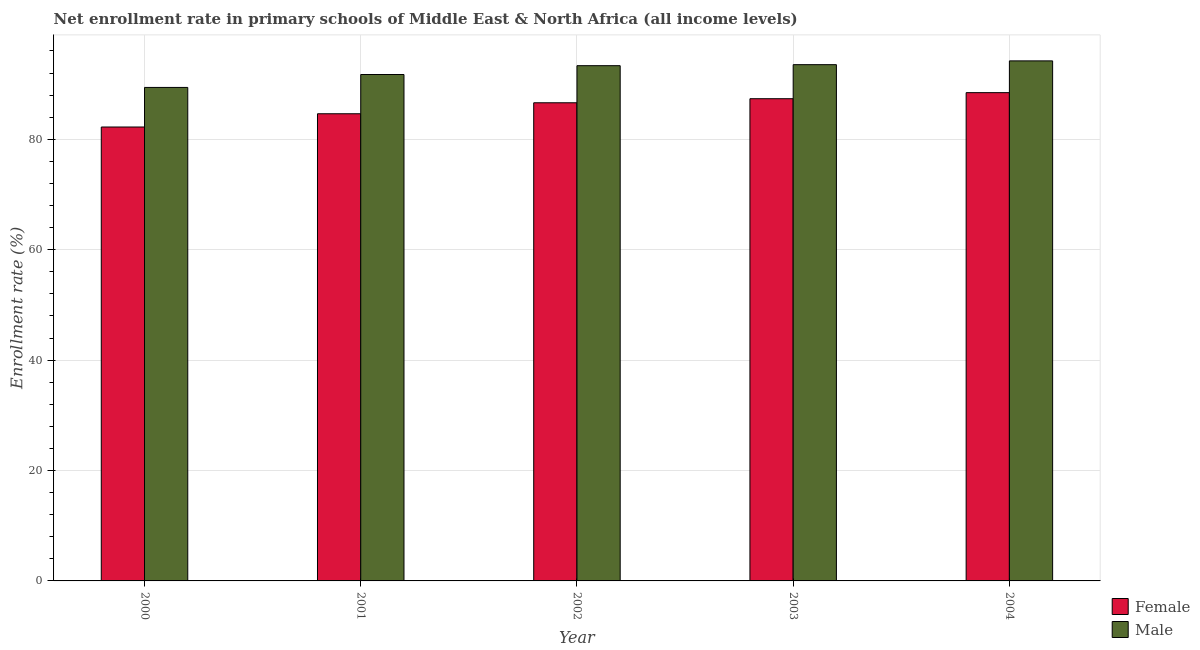How many different coloured bars are there?
Offer a terse response. 2. How many bars are there on the 3rd tick from the left?
Your response must be concise. 2. How many bars are there on the 1st tick from the right?
Your response must be concise. 2. In how many cases, is the number of bars for a given year not equal to the number of legend labels?
Your answer should be very brief. 0. What is the enrollment rate of female students in 2002?
Your answer should be compact. 86.61. Across all years, what is the maximum enrollment rate of male students?
Make the answer very short. 94.2. Across all years, what is the minimum enrollment rate of male students?
Make the answer very short. 89.39. In which year was the enrollment rate of female students maximum?
Offer a very short reply. 2004. In which year was the enrollment rate of female students minimum?
Keep it short and to the point. 2000. What is the total enrollment rate of female students in the graph?
Keep it short and to the point. 429.24. What is the difference between the enrollment rate of male students in 2000 and that in 2003?
Your response must be concise. -4.12. What is the difference between the enrollment rate of male students in 2001 and the enrollment rate of female students in 2000?
Your answer should be very brief. 2.34. What is the average enrollment rate of female students per year?
Give a very brief answer. 85.85. In the year 2004, what is the difference between the enrollment rate of female students and enrollment rate of male students?
Provide a succinct answer. 0. What is the ratio of the enrollment rate of female students in 2002 to that in 2003?
Give a very brief answer. 0.99. What is the difference between the highest and the second highest enrollment rate of female students?
Provide a short and direct response. 1.1. What is the difference between the highest and the lowest enrollment rate of female students?
Keep it short and to the point. 6.22. Is the sum of the enrollment rate of male students in 2001 and 2002 greater than the maximum enrollment rate of female students across all years?
Give a very brief answer. Yes. How many bars are there?
Ensure brevity in your answer.  10. Are all the bars in the graph horizontal?
Provide a succinct answer. No. What is the title of the graph?
Keep it short and to the point. Net enrollment rate in primary schools of Middle East & North Africa (all income levels). What is the label or title of the X-axis?
Make the answer very short. Year. What is the label or title of the Y-axis?
Ensure brevity in your answer.  Enrollment rate (%). What is the Enrollment rate (%) of Female in 2000?
Make the answer very short. 82.22. What is the Enrollment rate (%) of Male in 2000?
Provide a short and direct response. 89.39. What is the Enrollment rate (%) of Female in 2001?
Your response must be concise. 84.62. What is the Enrollment rate (%) of Male in 2001?
Your response must be concise. 91.73. What is the Enrollment rate (%) in Female in 2002?
Offer a very short reply. 86.61. What is the Enrollment rate (%) in Male in 2002?
Your answer should be very brief. 93.33. What is the Enrollment rate (%) in Female in 2003?
Keep it short and to the point. 87.35. What is the Enrollment rate (%) of Male in 2003?
Provide a short and direct response. 93.51. What is the Enrollment rate (%) in Female in 2004?
Ensure brevity in your answer.  88.44. What is the Enrollment rate (%) in Male in 2004?
Your answer should be very brief. 94.2. Across all years, what is the maximum Enrollment rate (%) of Female?
Make the answer very short. 88.44. Across all years, what is the maximum Enrollment rate (%) of Male?
Provide a succinct answer. 94.2. Across all years, what is the minimum Enrollment rate (%) in Female?
Ensure brevity in your answer.  82.22. Across all years, what is the minimum Enrollment rate (%) of Male?
Offer a very short reply. 89.39. What is the total Enrollment rate (%) of Female in the graph?
Provide a succinct answer. 429.24. What is the total Enrollment rate (%) of Male in the graph?
Keep it short and to the point. 462.16. What is the difference between the Enrollment rate (%) of Female in 2000 and that in 2001?
Offer a terse response. -2.4. What is the difference between the Enrollment rate (%) in Male in 2000 and that in 2001?
Provide a succinct answer. -2.34. What is the difference between the Enrollment rate (%) of Female in 2000 and that in 2002?
Offer a very short reply. -4.39. What is the difference between the Enrollment rate (%) of Male in 2000 and that in 2002?
Provide a short and direct response. -3.94. What is the difference between the Enrollment rate (%) in Female in 2000 and that in 2003?
Offer a very short reply. -5.13. What is the difference between the Enrollment rate (%) in Male in 2000 and that in 2003?
Offer a terse response. -4.12. What is the difference between the Enrollment rate (%) of Female in 2000 and that in 2004?
Ensure brevity in your answer.  -6.22. What is the difference between the Enrollment rate (%) of Male in 2000 and that in 2004?
Offer a very short reply. -4.81. What is the difference between the Enrollment rate (%) of Female in 2001 and that in 2002?
Keep it short and to the point. -1.99. What is the difference between the Enrollment rate (%) in Male in 2001 and that in 2002?
Give a very brief answer. -1.6. What is the difference between the Enrollment rate (%) in Female in 2001 and that in 2003?
Your answer should be very brief. -2.73. What is the difference between the Enrollment rate (%) of Male in 2001 and that in 2003?
Make the answer very short. -1.78. What is the difference between the Enrollment rate (%) of Female in 2001 and that in 2004?
Ensure brevity in your answer.  -3.82. What is the difference between the Enrollment rate (%) of Male in 2001 and that in 2004?
Offer a very short reply. -2.47. What is the difference between the Enrollment rate (%) of Female in 2002 and that in 2003?
Your answer should be very brief. -0.74. What is the difference between the Enrollment rate (%) of Male in 2002 and that in 2003?
Make the answer very short. -0.18. What is the difference between the Enrollment rate (%) in Female in 2002 and that in 2004?
Provide a short and direct response. -1.84. What is the difference between the Enrollment rate (%) of Male in 2002 and that in 2004?
Your response must be concise. -0.87. What is the difference between the Enrollment rate (%) in Female in 2003 and that in 2004?
Provide a succinct answer. -1.1. What is the difference between the Enrollment rate (%) in Male in 2003 and that in 2004?
Provide a succinct answer. -0.69. What is the difference between the Enrollment rate (%) of Female in 2000 and the Enrollment rate (%) of Male in 2001?
Provide a short and direct response. -9.51. What is the difference between the Enrollment rate (%) of Female in 2000 and the Enrollment rate (%) of Male in 2002?
Offer a terse response. -11.11. What is the difference between the Enrollment rate (%) of Female in 2000 and the Enrollment rate (%) of Male in 2003?
Your answer should be compact. -11.29. What is the difference between the Enrollment rate (%) of Female in 2000 and the Enrollment rate (%) of Male in 2004?
Make the answer very short. -11.98. What is the difference between the Enrollment rate (%) of Female in 2001 and the Enrollment rate (%) of Male in 2002?
Provide a short and direct response. -8.71. What is the difference between the Enrollment rate (%) of Female in 2001 and the Enrollment rate (%) of Male in 2003?
Offer a very short reply. -8.89. What is the difference between the Enrollment rate (%) of Female in 2001 and the Enrollment rate (%) of Male in 2004?
Make the answer very short. -9.58. What is the difference between the Enrollment rate (%) of Female in 2002 and the Enrollment rate (%) of Male in 2003?
Provide a succinct answer. -6.9. What is the difference between the Enrollment rate (%) of Female in 2002 and the Enrollment rate (%) of Male in 2004?
Provide a succinct answer. -7.59. What is the difference between the Enrollment rate (%) in Female in 2003 and the Enrollment rate (%) in Male in 2004?
Offer a very short reply. -6.85. What is the average Enrollment rate (%) of Female per year?
Provide a succinct answer. 85.85. What is the average Enrollment rate (%) of Male per year?
Your answer should be very brief. 92.43. In the year 2000, what is the difference between the Enrollment rate (%) in Female and Enrollment rate (%) in Male?
Your answer should be compact. -7.17. In the year 2001, what is the difference between the Enrollment rate (%) of Female and Enrollment rate (%) of Male?
Ensure brevity in your answer.  -7.11. In the year 2002, what is the difference between the Enrollment rate (%) of Female and Enrollment rate (%) of Male?
Your answer should be compact. -6.72. In the year 2003, what is the difference between the Enrollment rate (%) of Female and Enrollment rate (%) of Male?
Provide a short and direct response. -6.17. In the year 2004, what is the difference between the Enrollment rate (%) in Female and Enrollment rate (%) in Male?
Ensure brevity in your answer.  -5.75. What is the ratio of the Enrollment rate (%) of Female in 2000 to that in 2001?
Provide a short and direct response. 0.97. What is the ratio of the Enrollment rate (%) of Male in 2000 to that in 2001?
Make the answer very short. 0.97. What is the ratio of the Enrollment rate (%) of Female in 2000 to that in 2002?
Provide a succinct answer. 0.95. What is the ratio of the Enrollment rate (%) in Male in 2000 to that in 2002?
Your answer should be compact. 0.96. What is the ratio of the Enrollment rate (%) of Female in 2000 to that in 2003?
Your answer should be very brief. 0.94. What is the ratio of the Enrollment rate (%) in Male in 2000 to that in 2003?
Your answer should be very brief. 0.96. What is the ratio of the Enrollment rate (%) of Female in 2000 to that in 2004?
Your answer should be compact. 0.93. What is the ratio of the Enrollment rate (%) in Male in 2000 to that in 2004?
Your answer should be very brief. 0.95. What is the ratio of the Enrollment rate (%) in Male in 2001 to that in 2002?
Ensure brevity in your answer.  0.98. What is the ratio of the Enrollment rate (%) of Female in 2001 to that in 2003?
Your answer should be very brief. 0.97. What is the ratio of the Enrollment rate (%) of Male in 2001 to that in 2003?
Your response must be concise. 0.98. What is the ratio of the Enrollment rate (%) of Female in 2001 to that in 2004?
Provide a succinct answer. 0.96. What is the ratio of the Enrollment rate (%) of Male in 2001 to that in 2004?
Give a very brief answer. 0.97. What is the ratio of the Enrollment rate (%) of Male in 2002 to that in 2003?
Offer a terse response. 1. What is the ratio of the Enrollment rate (%) in Female in 2002 to that in 2004?
Provide a short and direct response. 0.98. What is the ratio of the Enrollment rate (%) in Female in 2003 to that in 2004?
Provide a short and direct response. 0.99. What is the ratio of the Enrollment rate (%) in Male in 2003 to that in 2004?
Provide a short and direct response. 0.99. What is the difference between the highest and the second highest Enrollment rate (%) in Female?
Your response must be concise. 1.1. What is the difference between the highest and the second highest Enrollment rate (%) in Male?
Your answer should be compact. 0.69. What is the difference between the highest and the lowest Enrollment rate (%) in Female?
Provide a succinct answer. 6.22. What is the difference between the highest and the lowest Enrollment rate (%) of Male?
Offer a very short reply. 4.81. 